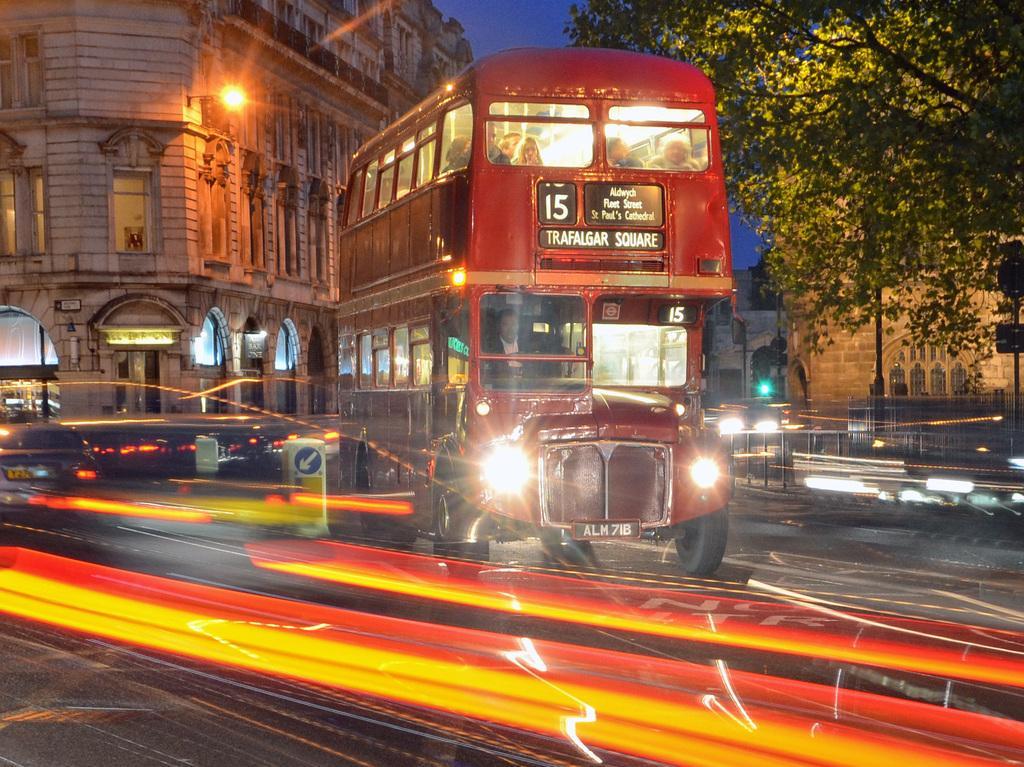Can you describe this image briefly? In this picture we can see a bus and a car on the road, fence, lights, buildings with windows, tree and in the background we can see the sky. 